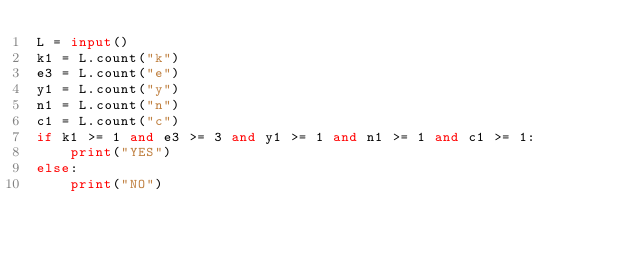<code> <loc_0><loc_0><loc_500><loc_500><_Python_>L = input()
k1 = L.count("k")
e3 = L.count("e")
y1 = L.count("y")
n1 = L.count("n")
c1 = L.count("c")
if k1 >= 1 and e3 >= 3 and y1 >= 1 and n1 >= 1 and c1 >= 1:
    print("YES")
else:
    print("NO")</code> 